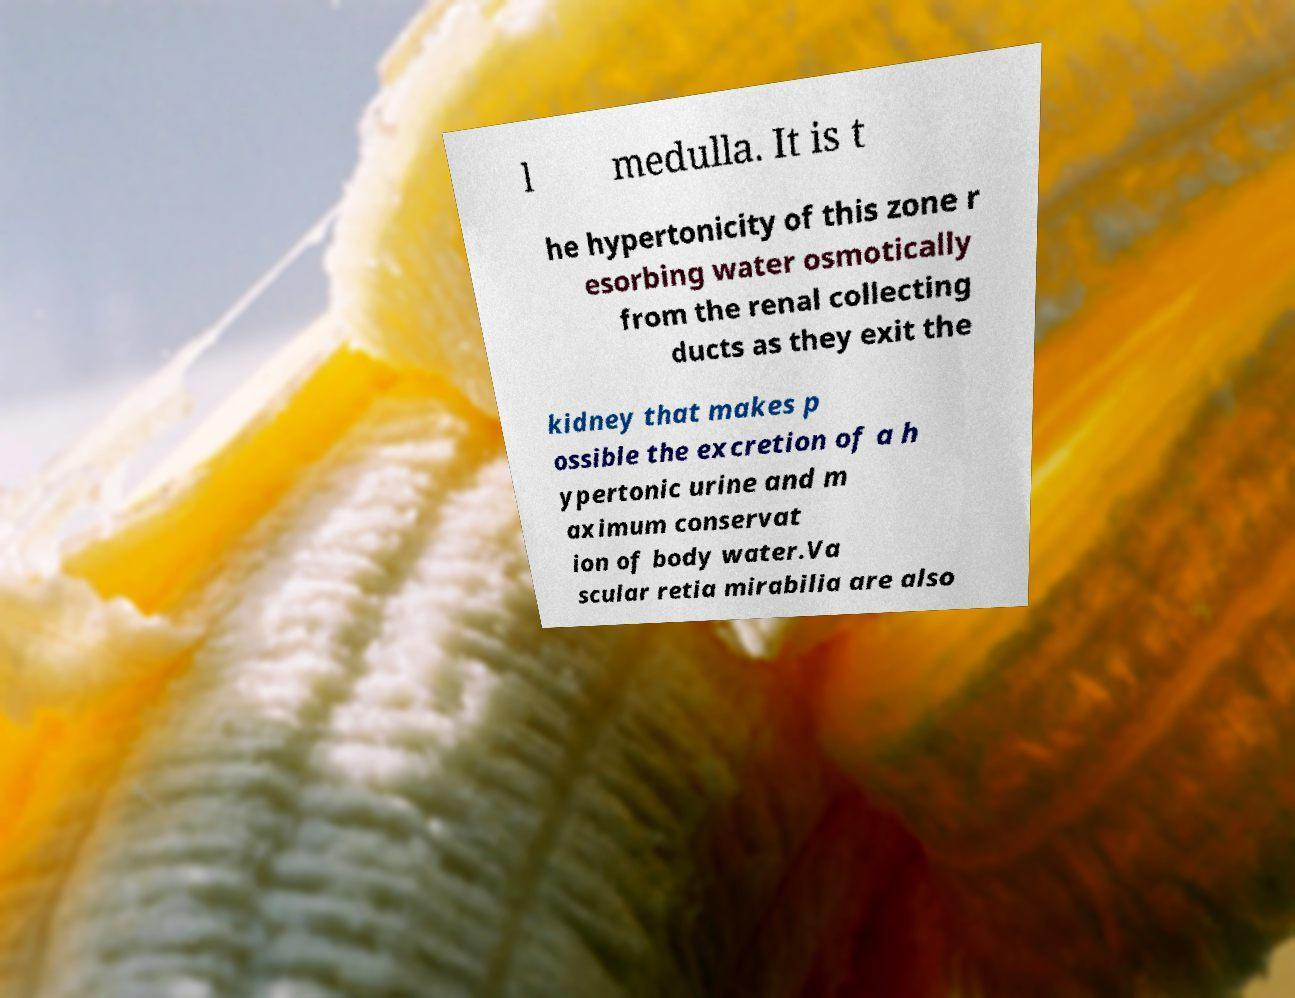Could you assist in decoding the text presented in this image and type it out clearly? l medulla. It is t he hypertonicity of this zone r esorbing water osmotically from the renal collecting ducts as they exit the kidney that makes p ossible the excretion of a h ypertonic urine and m aximum conservat ion of body water.Va scular retia mirabilia are also 